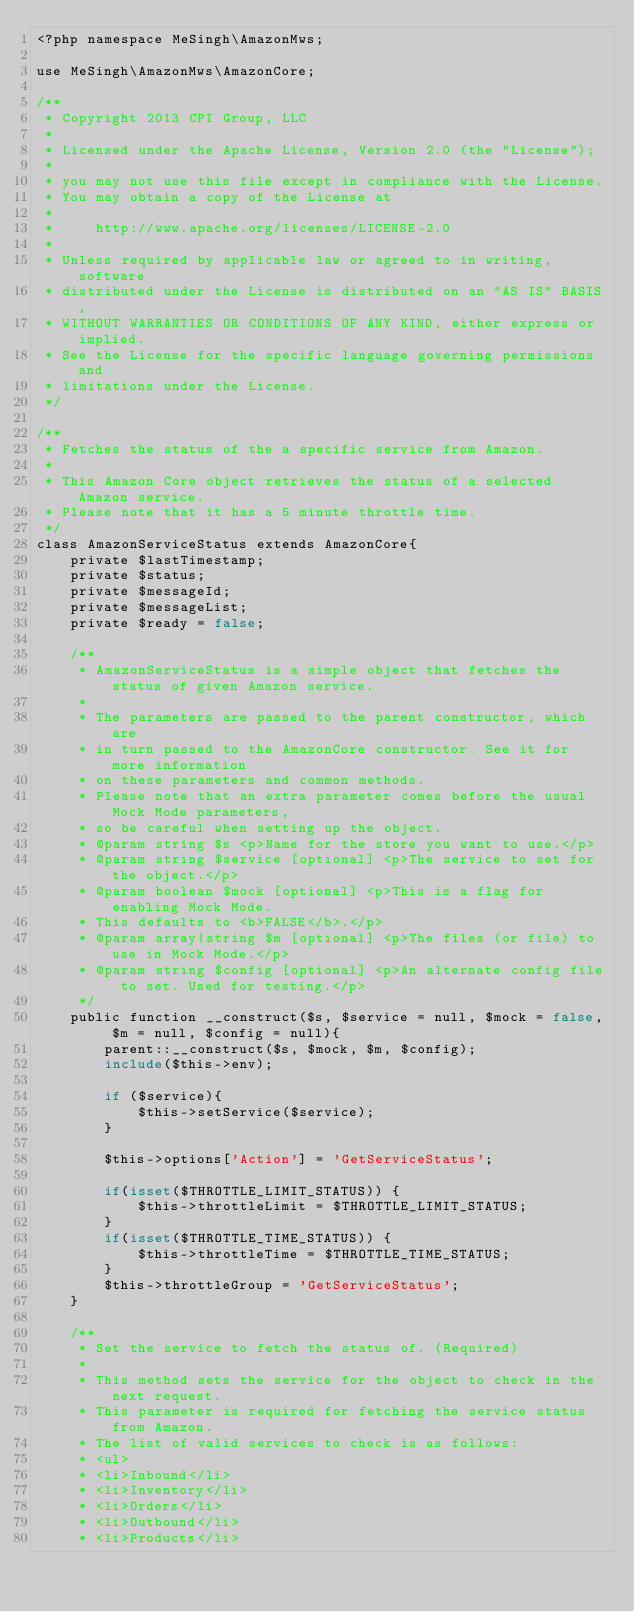<code> <loc_0><loc_0><loc_500><loc_500><_PHP_><?php namespace MeSingh\AmazonMws;

use MeSingh\AmazonMws\AmazonCore;

/**
 * Copyright 2013 CPI Group, LLC
 *
 * Licensed under the Apache License, Version 2.0 (the "License");
 *
 * you may not use this file except in compliance with the License.
 * You may obtain a copy of the License at
 *
 *     http://www.apache.org/licenses/LICENSE-2.0
 *
 * Unless required by applicable law or agreed to in writing, software
 * distributed under the License is distributed on an "AS IS" BASIS,
 * WITHOUT WARRANTIES OR CONDITIONS OF ANY KIND, either express or implied.
 * See the License for the specific language governing permissions and
 * limitations under the License.
 */

/**
 * Fetches the status of the a specific service from Amazon.
 *
 * This Amazon Core object retrieves the status of a selected Amazon service.
 * Please note that it has a 5 minute throttle time.
 */
class AmazonServiceStatus extends AmazonCore{
    private $lastTimestamp;
    private $status;
    private $messageId;
    private $messageList;
    private $ready = false;

    /**
     * AmazonServiceStatus is a simple object that fetches the status of given Amazon service.
     *
     * The parameters are passed to the parent constructor, which are
     * in turn passed to the AmazonCore constructor. See it for more information
     * on these parameters and common methods.
     * Please note that an extra parameter comes before the usual Mock Mode parameters,
     * so be careful when setting up the object.
     * @param string $s <p>Name for the store you want to use.</p>
     * @param string $service [optional] <p>The service to set for the object.</p>
     * @param boolean $mock [optional] <p>This is a flag for enabling Mock Mode.
     * This defaults to <b>FALSE</b>.</p>
     * @param array|string $m [optional] <p>The files (or file) to use in Mock Mode.</p>
     * @param string $config [optional] <p>An alternate config file to set. Used for testing.</p>
     */
    public function __construct($s, $service = null, $mock = false, $m = null, $config = null){
        parent::__construct($s, $mock, $m, $config);
        include($this->env);

        if ($service){
            $this->setService($service);
        }

        $this->options['Action'] = 'GetServiceStatus';

        if(isset($THROTTLE_LIMIT_STATUS)) {
            $this->throttleLimit = $THROTTLE_LIMIT_STATUS;
        }
        if(isset($THROTTLE_TIME_STATUS)) {
            $this->throttleTime = $THROTTLE_TIME_STATUS;
        }
        $this->throttleGroup = 'GetServiceStatus';
    }

    /**
     * Set the service to fetch the status of. (Required)
     *
     * This method sets the service for the object to check in the next request.
     * This parameter is required for fetching the service status from Amazon.
     * The list of valid services to check is as follows:
     * <ul>
     * <li>Inbound</li>
     * <li>Inventory</li>
     * <li>Orders</li>
     * <li>Outbound</li>
     * <li>Products</li></code> 